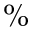Convert formula to latex. <formula><loc_0><loc_0><loc_500><loc_500>\%</formula> 